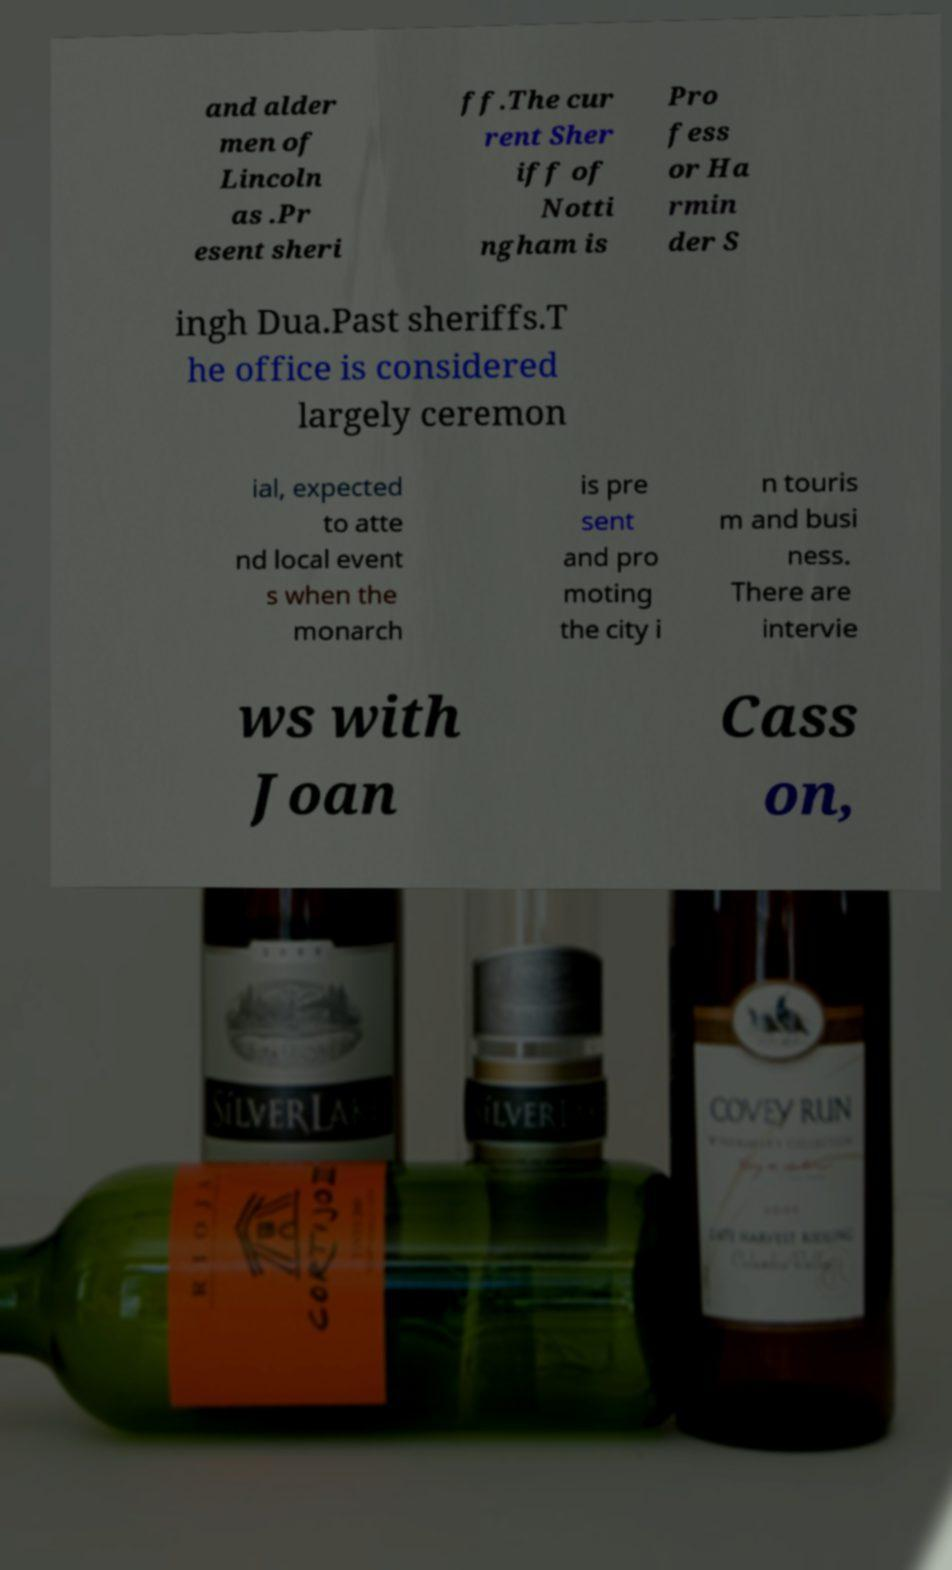Could you assist in decoding the text presented in this image and type it out clearly? and alder men of Lincoln as .Pr esent sheri ff.The cur rent Sher iff of Notti ngham is Pro fess or Ha rmin der S ingh Dua.Past sheriffs.T he office is considered largely ceremon ial, expected to atte nd local event s when the monarch is pre sent and pro moting the city i n touris m and busi ness. There are intervie ws with Joan Cass on, 